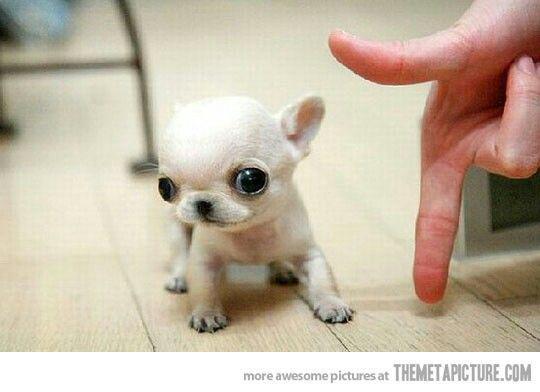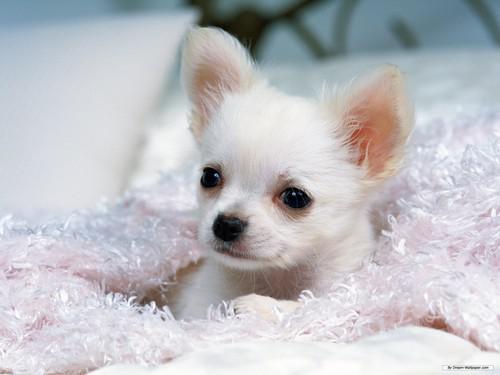The first image is the image on the left, the second image is the image on the right. Analyze the images presented: Is the assertion "A person's hand is shown in one of the images." valid? Answer yes or no. Yes. 